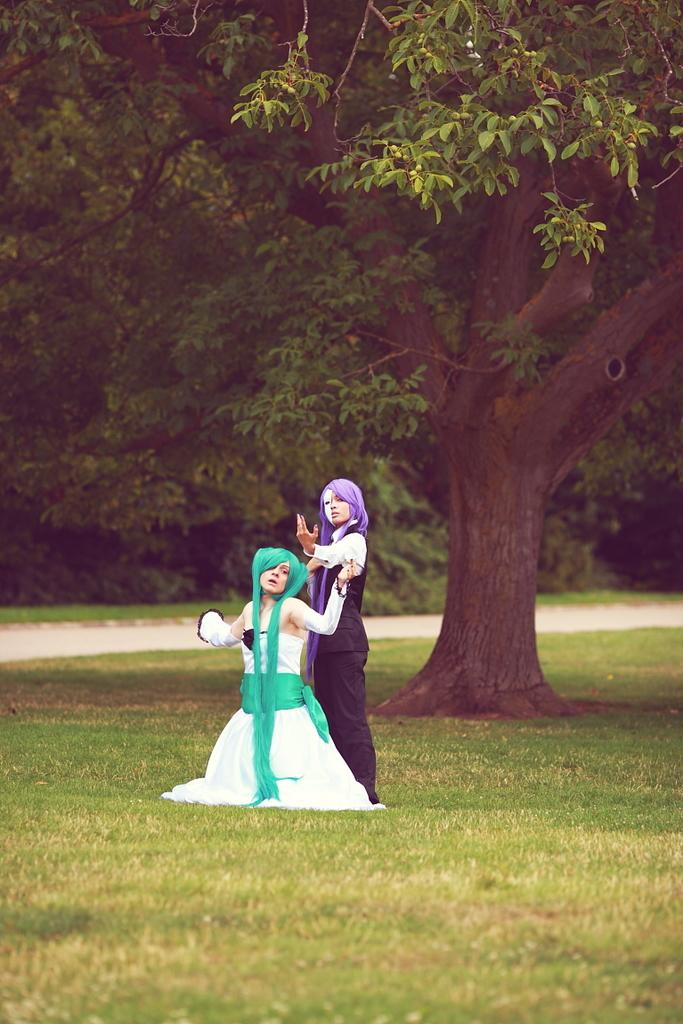How many people are in the image? There are two persons in the image. What are the persons wearing? The persons are wearing different costumes. What type of vegetation can be seen in the background of the image? There are trees visible at the back of the image. What is the ground made of in the image? There is grass at the bottom of the image. What type of pathway is present in the image? There is a road in the image. What month is it in the image? The month cannot be determined from the image, as there is no information about the time of year. What type of cream is being used by the persons in the image? There is no cream visible in the image, and the persons are wearing costumes, not applying any cream. 